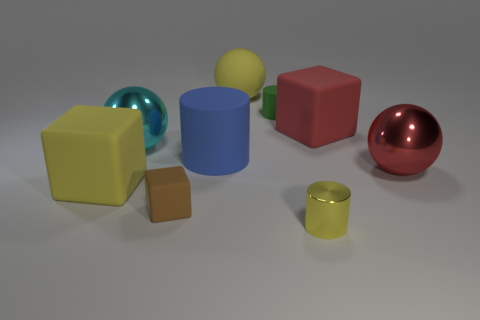Add 1 tiny yellow objects. How many objects exist? 10 Subtract all cubes. How many objects are left? 6 Subtract 0 purple cylinders. How many objects are left? 9 Subtract all tiny matte cylinders. Subtract all yellow spheres. How many objects are left? 7 Add 3 cyan spheres. How many cyan spheres are left? 4 Add 8 red matte balls. How many red matte balls exist? 8 